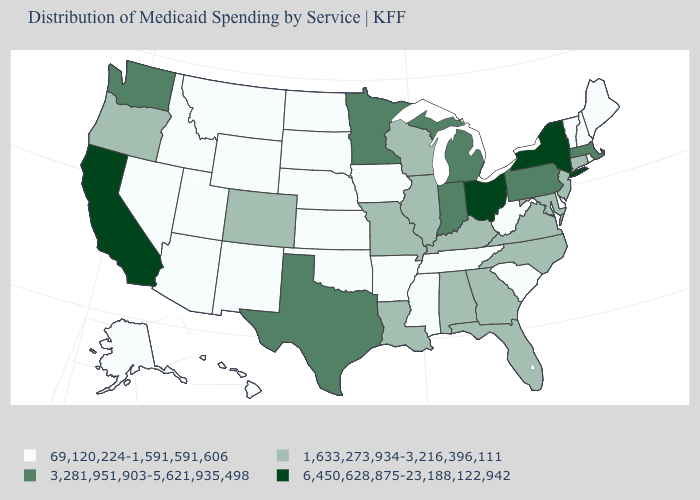Does the map have missing data?
Short answer required. No. Does the first symbol in the legend represent the smallest category?
Short answer required. Yes. What is the lowest value in the USA?
Answer briefly. 69,120,224-1,591,591,606. What is the value of New Jersey?
Keep it brief. 1,633,273,934-3,216,396,111. Name the states that have a value in the range 1,633,273,934-3,216,396,111?
Short answer required. Alabama, Colorado, Connecticut, Florida, Georgia, Illinois, Kentucky, Louisiana, Maryland, Missouri, New Jersey, North Carolina, Oregon, Virginia, Wisconsin. Does Wisconsin have the lowest value in the MidWest?
Quick response, please. No. Among the states that border Iowa , which have the lowest value?
Write a very short answer. Nebraska, South Dakota. Does Mississippi have the lowest value in the USA?
Write a very short answer. Yes. What is the value of Michigan?
Be succinct. 3,281,951,903-5,621,935,498. What is the value of Arkansas?
Answer briefly. 69,120,224-1,591,591,606. What is the value of Indiana?
Be succinct. 3,281,951,903-5,621,935,498. What is the value of Florida?
Be succinct. 1,633,273,934-3,216,396,111. Which states hav the highest value in the West?
Keep it brief. California. Name the states that have a value in the range 6,450,628,875-23,188,122,942?
Short answer required. California, New York, Ohio. Does Maryland have the lowest value in the USA?
Be succinct. No. 